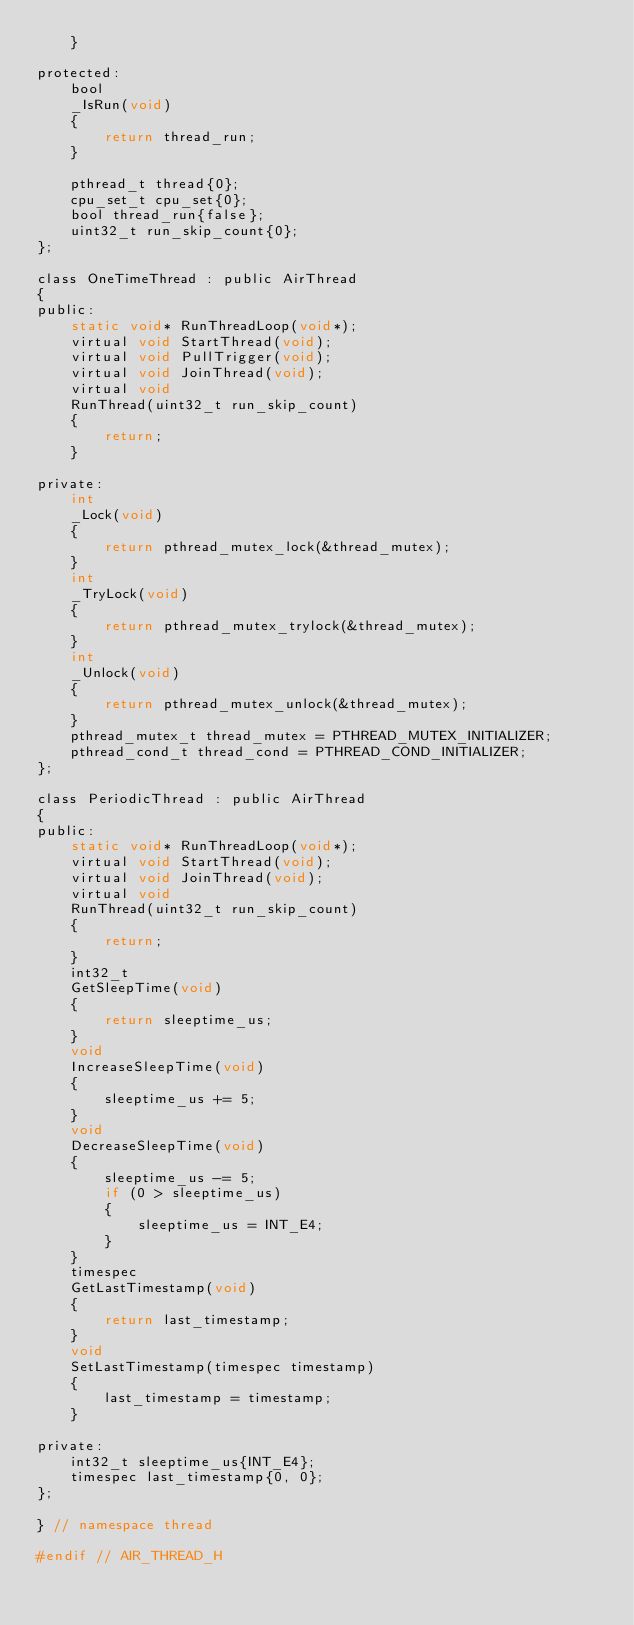<code> <loc_0><loc_0><loc_500><loc_500><_C_>    }

protected:
    bool
    _IsRun(void)
    {
        return thread_run;
    }

    pthread_t thread{0};
    cpu_set_t cpu_set{0};
    bool thread_run{false};
    uint32_t run_skip_count{0};
};

class OneTimeThread : public AirThread
{
public:
    static void* RunThreadLoop(void*);
    virtual void StartThread(void);
    virtual void PullTrigger(void);
    virtual void JoinThread(void);
    virtual void
    RunThread(uint32_t run_skip_count)
    {
        return;
    }

private:
    int
    _Lock(void)
    {
        return pthread_mutex_lock(&thread_mutex);
    }
    int
    _TryLock(void)
    {
        return pthread_mutex_trylock(&thread_mutex);
    }
    int
    _Unlock(void)
    {
        return pthread_mutex_unlock(&thread_mutex);
    }
    pthread_mutex_t thread_mutex = PTHREAD_MUTEX_INITIALIZER;
    pthread_cond_t thread_cond = PTHREAD_COND_INITIALIZER;
};

class PeriodicThread : public AirThread
{
public:
    static void* RunThreadLoop(void*);
    virtual void StartThread(void);
    virtual void JoinThread(void);
    virtual void
    RunThread(uint32_t run_skip_count)
    {
        return;
    }
    int32_t
    GetSleepTime(void)
    {
        return sleeptime_us;
    }
    void
    IncreaseSleepTime(void)
    {
        sleeptime_us += 5;
    }
    void
    DecreaseSleepTime(void)
    {
        sleeptime_us -= 5;
        if (0 > sleeptime_us)
        {
            sleeptime_us = INT_E4;
        }
    }
    timespec
    GetLastTimestamp(void)
    {
        return last_timestamp;
    }
    void
    SetLastTimestamp(timespec timestamp)
    {
        last_timestamp = timestamp;
    }

private:
    int32_t sleeptime_us{INT_E4};
    timespec last_timestamp{0, 0};
};

} // namespace thread

#endif // AIR_THREAD_H
</code> 